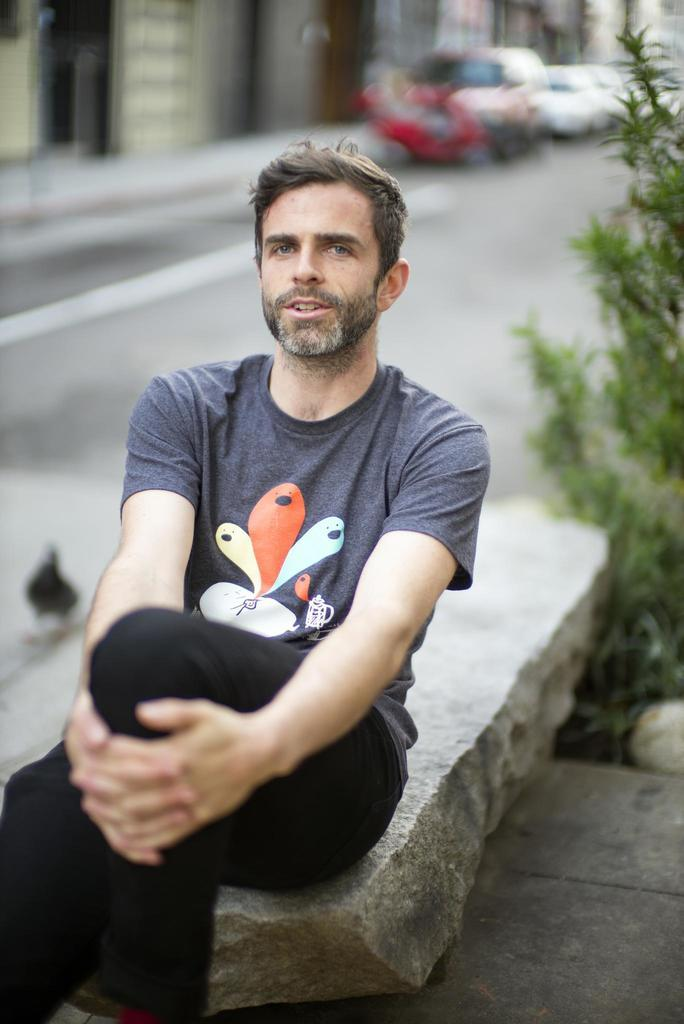What is the man in the image doing? The man is sitting on a stone in the image. What can be seen in the background of the image? There are plants, vehicles on the road, and buildings in the background of the image. Can you tell me how many goats are standing next to the man in the image? There are no goats present in the image. What type of scarecrow can be seen in the image? There is no scarecrow present in the image. 